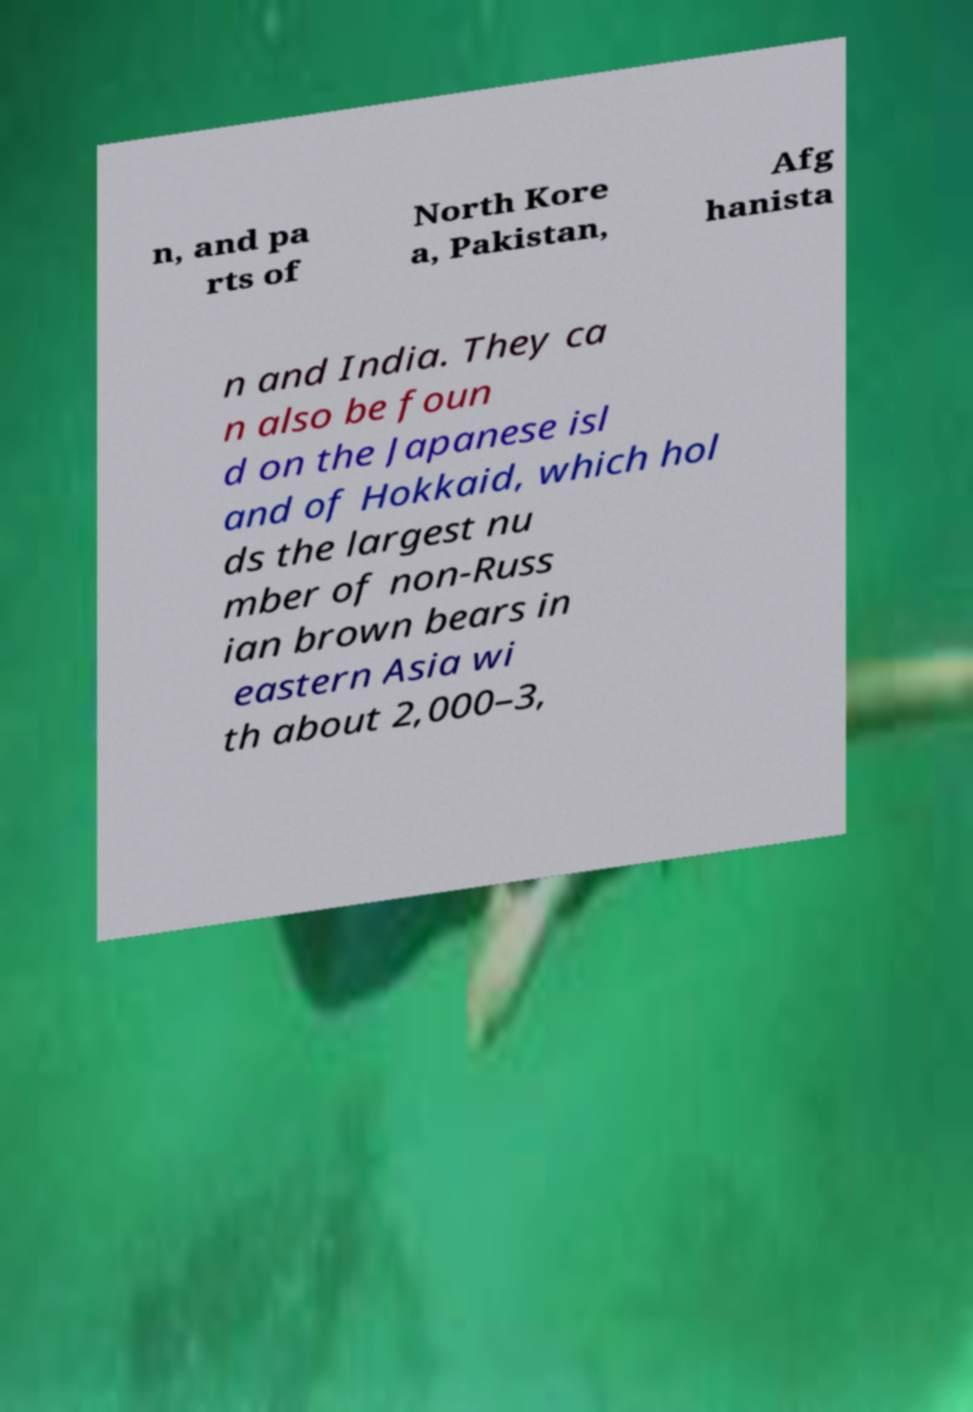Please identify and transcribe the text found in this image. n, and pa rts of North Kore a, Pakistan, Afg hanista n and India. They ca n also be foun d on the Japanese isl and of Hokkaid, which hol ds the largest nu mber of non-Russ ian brown bears in eastern Asia wi th about 2,000–3, 